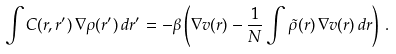<formula> <loc_0><loc_0><loc_500><loc_500>\int C ( r , r ^ { \prime } ) \, \nabla \rho ( r ^ { \prime } ) \, d r ^ { \prime } = - \beta \left ( \nabla v ( r ) - \frac { 1 } { N } \int \tilde { \rho } ( r ) \, \nabla v ( r ) \, d r \right ) \, .</formula> 